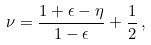<formula> <loc_0><loc_0><loc_500><loc_500>\nu = \frac { 1 + \epsilon - \eta } { 1 - \epsilon } + \frac { 1 } { 2 } \, ,</formula> 